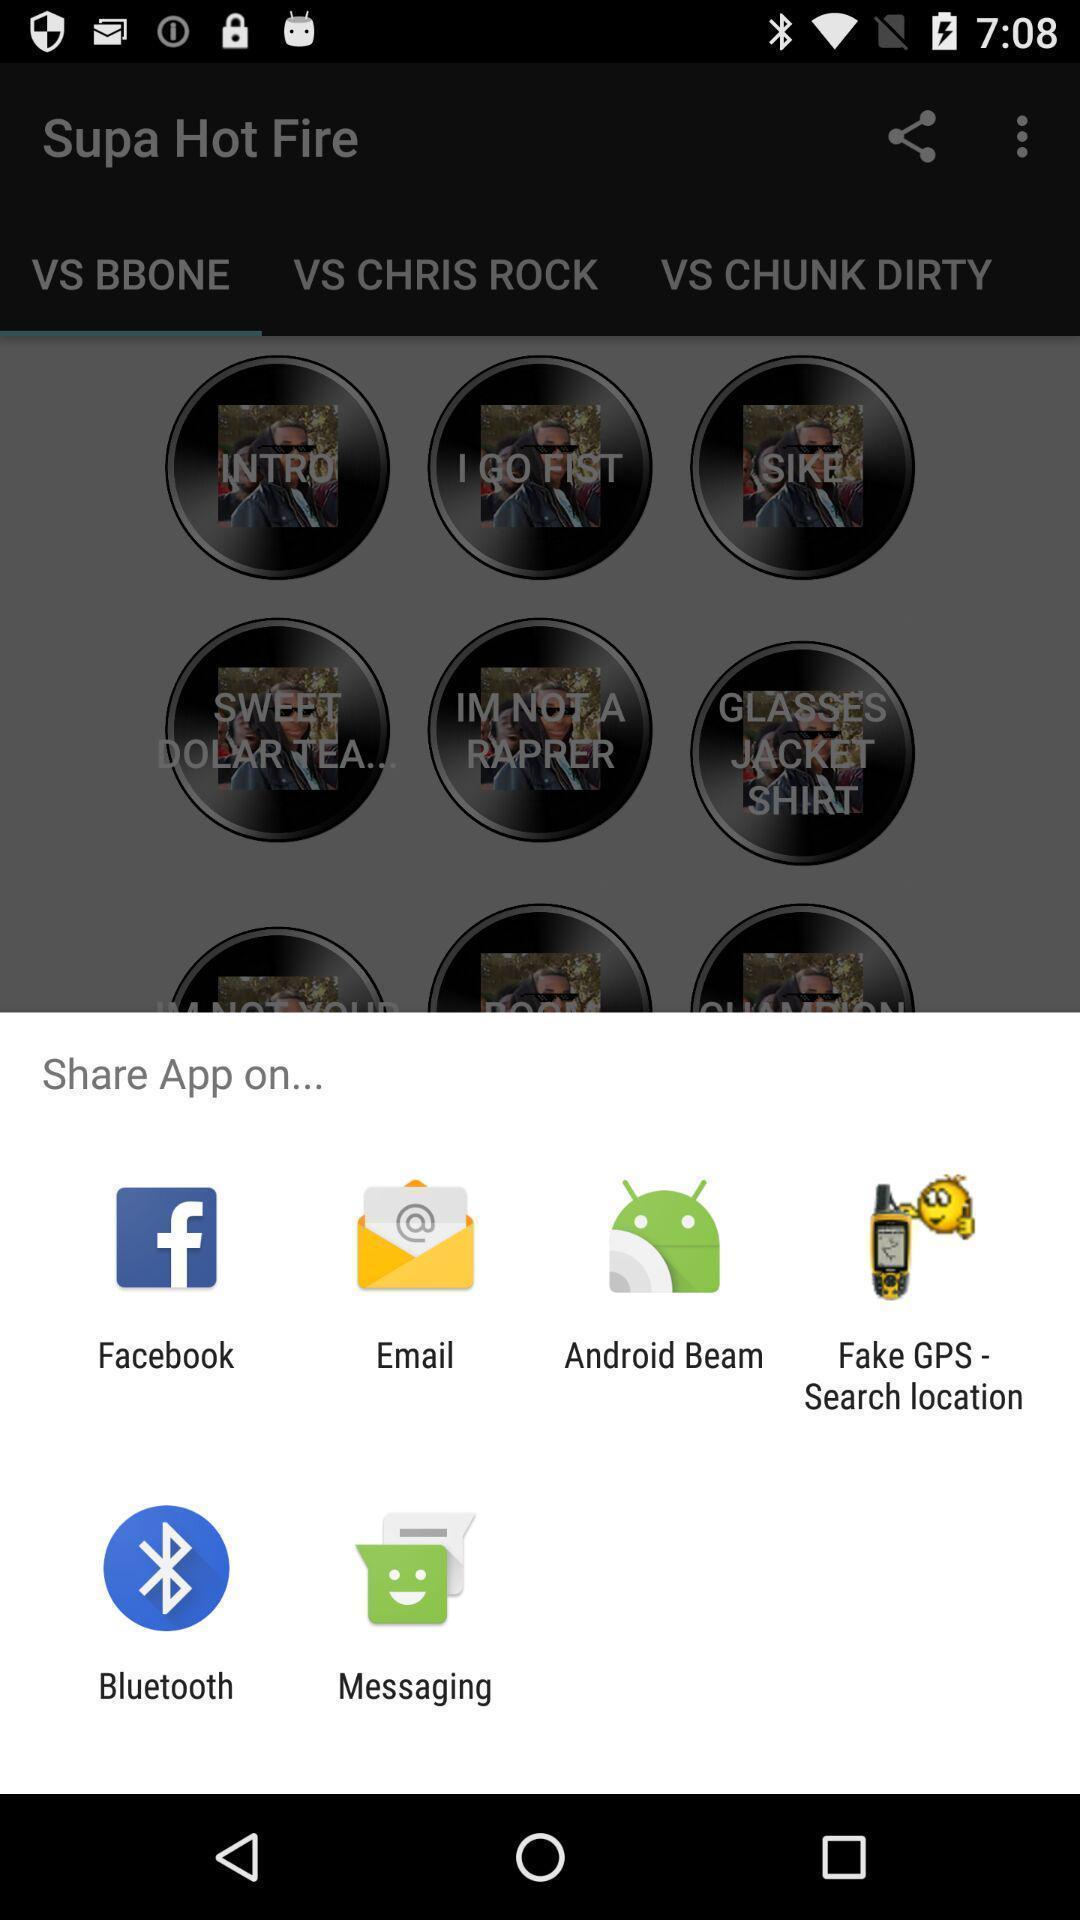Describe the visual elements of this screenshot. Pop-up to share an app via different apps. 